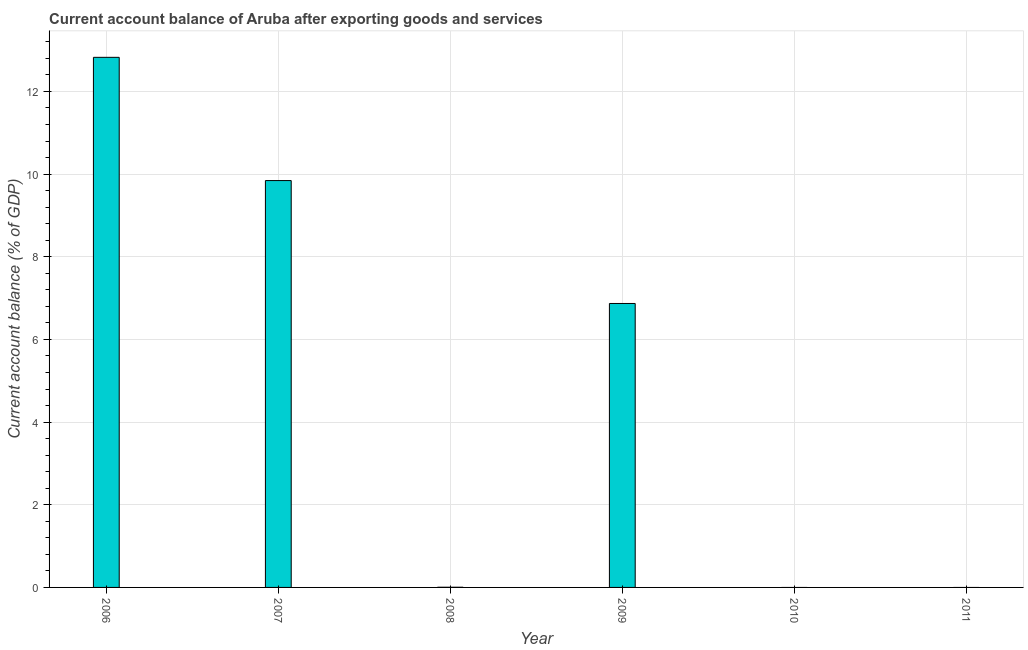Does the graph contain any zero values?
Offer a terse response. Yes. Does the graph contain grids?
Your response must be concise. Yes. What is the title of the graph?
Keep it short and to the point. Current account balance of Aruba after exporting goods and services. What is the label or title of the Y-axis?
Provide a short and direct response. Current account balance (% of GDP). What is the current account balance in 2006?
Keep it short and to the point. 12.83. Across all years, what is the maximum current account balance?
Provide a short and direct response. 12.83. What is the sum of the current account balance?
Provide a short and direct response. 29.54. What is the difference between the current account balance in 2006 and 2009?
Your answer should be very brief. 5.96. What is the average current account balance per year?
Your answer should be very brief. 4.92. What is the median current account balance?
Your answer should be compact. 3.44. What is the difference between the highest and the second highest current account balance?
Your answer should be compact. 2.98. What is the difference between the highest and the lowest current account balance?
Your answer should be very brief. 12.83. In how many years, is the current account balance greater than the average current account balance taken over all years?
Offer a terse response. 3. Are all the bars in the graph horizontal?
Ensure brevity in your answer.  No. Are the values on the major ticks of Y-axis written in scientific E-notation?
Offer a terse response. No. What is the Current account balance (% of GDP) of 2006?
Your answer should be compact. 12.83. What is the Current account balance (% of GDP) in 2007?
Offer a terse response. 9.84. What is the Current account balance (% of GDP) in 2008?
Your response must be concise. 0. What is the Current account balance (% of GDP) in 2009?
Your answer should be compact. 6.87. What is the difference between the Current account balance (% of GDP) in 2006 and 2007?
Your answer should be very brief. 2.98. What is the difference between the Current account balance (% of GDP) in 2006 and 2008?
Your answer should be compact. 12.82. What is the difference between the Current account balance (% of GDP) in 2006 and 2009?
Your answer should be compact. 5.96. What is the difference between the Current account balance (% of GDP) in 2007 and 2008?
Your answer should be compact. 9.84. What is the difference between the Current account balance (% of GDP) in 2007 and 2009?
Offer a terse response. 2.97. What is the difference between the Current account balance (% of GDP) in 2008 and 2009?
Your answer should be very brief. -6.87. What is the ratio of the Current account balance (% of GDP) in 2006 to that in 2007?
Your answer should be very brief. 1.3. What is the ratio of the Current account balance (% of GDP) in 2006 to that in 2008?
Offer a terse response. 3204.73. What is the ratio of the Current account balance (% of GDP) in 2006 to that in 2009?
Make the answer very short. 1.87. What is the ratio of the Current account balance (% of GDP) in 2007 to that in 2008?
Provide a short and direct response. 2459.72. What is the ratio of the Current account balance (% of GDP) in 2007 to that in 2009?
Your answer should be very brief. 1.43. What is the ratio of the Current account balance (% of GDP) in 2008 to that in 2009?
Offer a terse response. 0. 